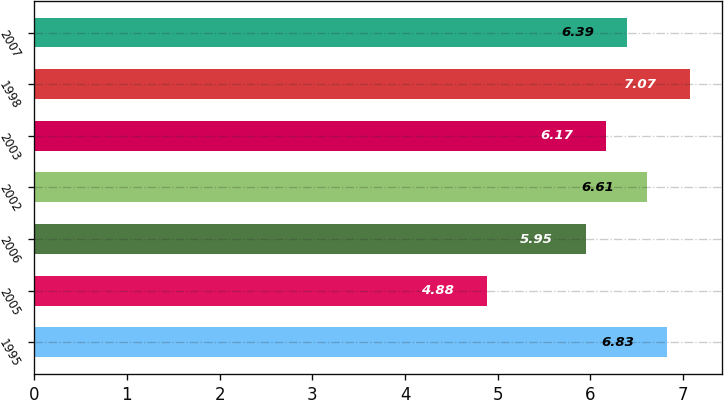<chart> <loc_0><loc_0><loc_500><loc_500><bar_chart><fcel>1995<fcel>2005<fcel>2006<fcel>2002<fcel>2003<fcel>1998<fcel>2007<nl><fcel>6.83<fcel>4.88<fcel>5.95<fcel>6.61<fcel>6.17<fcel>7.07<fcel>6.39<nl></chart> 